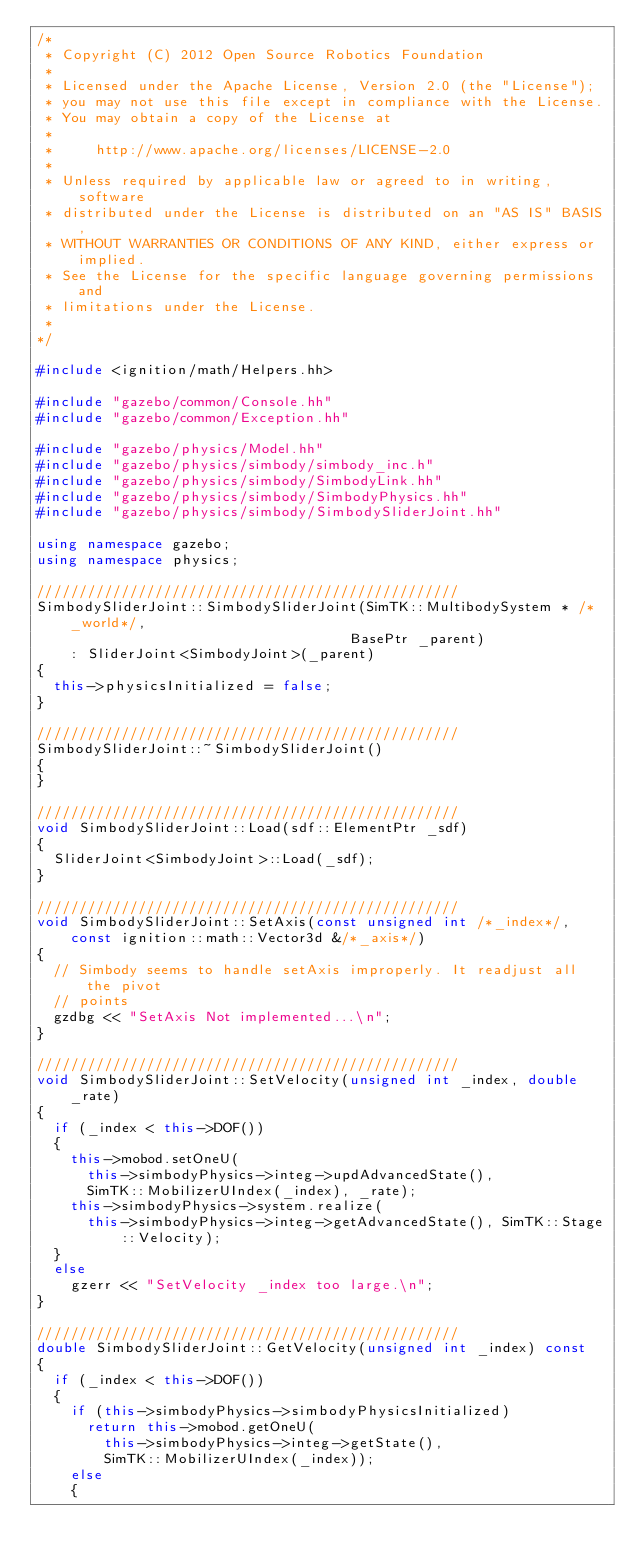<code> <loc_0><loc_0><loc_500><loc_500><_C++_>/*
 * Copyright (C) 2012 Open Source Robotics Foundation
 *
 * Licensed under the Apache License, Version 2.0 (the "License");
 * you may not use this file except in compliance with the License.
 * You may obtain a copy of the License at
 *
 *     http://www.apache.org/licenses/LICENSE-2.0
 *
 * Unless required by applicable law or agreed to in writing, software
 * distributed under the License is distributed on an "AS IS" BASIS,
 * WITHOUT WARRANTIES OR CONDITIONS OF ANY KIND, either express or implied.
 * See the License for the specific language governing permissions and
 * limitations under the License.
 *
*/

#include <ignition/math/Helpers.hh>

#include "gazebo/common/Console.hh"
#include "gazebo/common/Exception.hh"

#include "gazebo/physics/Model.hh"
#include "gazebo/physics/simbody/simbody_inc.h"
#include "gazebo/physics/simbody/SimbodyLink.hh"
#include "gazebo/physics/simbody/SimbodyPhysics.hh"
#include "gazebo/physics/simbody/SimbodySliderJoint.hh"

using namespace gazebo;
using namespace physics;

//////////////////////////////////////////////////
SimbodySliderJoint::SimbodySliderJoint(SimTK::MultibodySystem * /*_world*/,
                                     BasePtr _parent)
    : SliderJoint<SimbodyJoint>(_parent)
{
  this->physicsInitialized = false;
}

//////////////////////////////////////////////////
SimbodySliderJoint::~SimbodySliderJoint()
{
}

//////////////////////////////////////////////////
void SimbodySliderJoint::Load(sdf::ElementPtr _sdf)
{
  SliderJoint<SimbodyJoint>::Load(_sdf);
}

//////////////////////////////////////////////////
void SimbodySliderJoint::SetAxis(const unsigned int /*_index*/,
    const ignition::math::Vector3d &/*_axis*/)
{
  // Simbody seems to handle setAxis improperly. It readjust all the pivot
  // points
  gzdbg << "SetAxis Not implemented...\n";
}

//////////////////////////////////////////////////
void SimbodySliderJoint::SetVelocity(unsigned int _index, double _rate)
{
  if (_index < this->DOF())
  {
    this->mobod.setOneU(
      this->simbodyPhysics->integ->updAdvancedState(),
      SimTK::MobilizerUIndex(_index), _rate);
    this->simbodyPhysics->system.realize(
      this->simbodyPhysics->integ->getAdvancedState(), SimTK::Stage::Velocity);
  }
  else
    gzerr << "SetVelocity _index too large.\n";
}

//////////////////////////////////////////////////
double SimbodySliderJoint::GetVelocity(unsigned int _index) const
{
  if (_index < this->DOF())
  {
    if (this->simbodyPhysics->simbodyPhysicsInitialized)
      return this->mobod.getOneU(
        this->simbodyPhysics->integ->getState(),
        SimTK::MobilizerUIndex(_index));
    else
    {</code> 